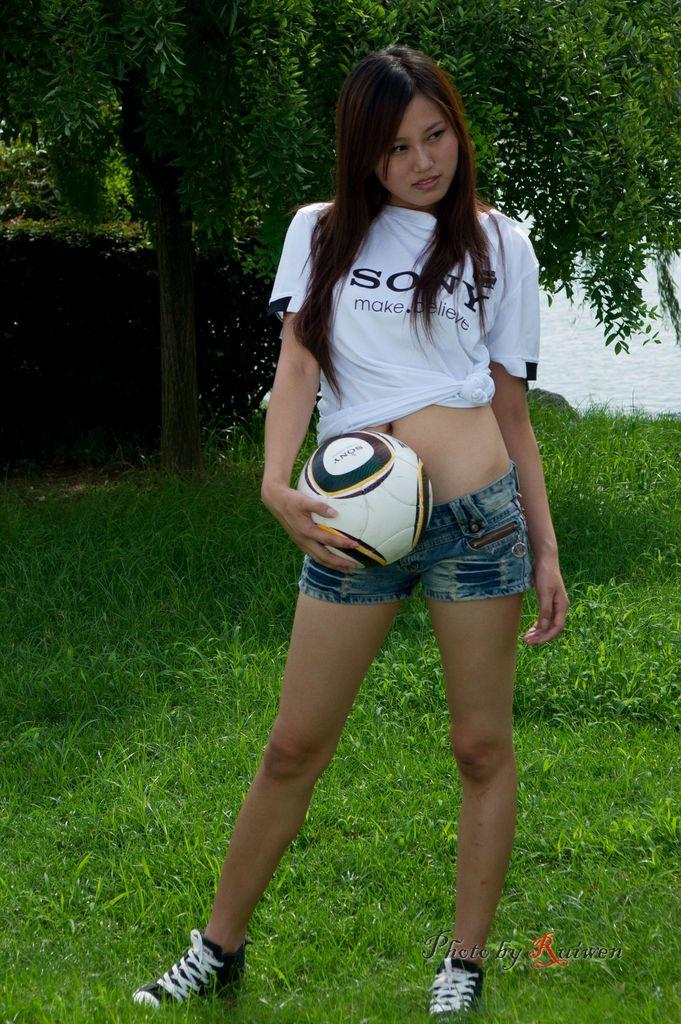Who is present in the image? There is a woman in the image. What is the woman holding in her hand? The woman is holding a ball with her hand. Where is the woman standing? The woman is standing on the grass. What can be seen in the background of the image? There is a tree and water visible in the background of the image. What is the temperature of the water in the image? The temperature of the water cannot be determined from the image, as there is no information provided about the water's temperature. 